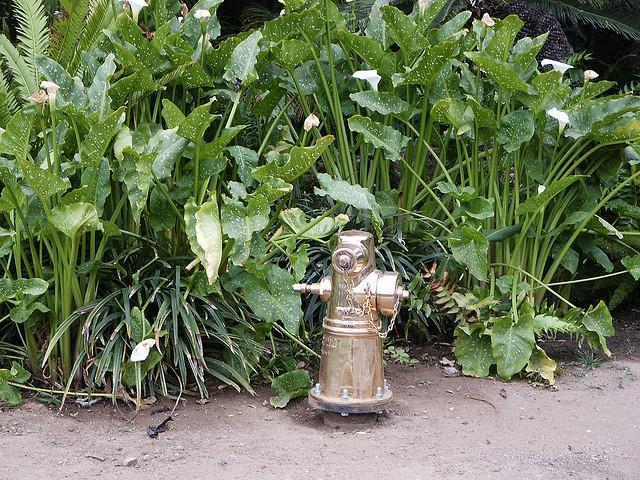How many people are wearing a red helmet?
Give a very brief answer. 0. 